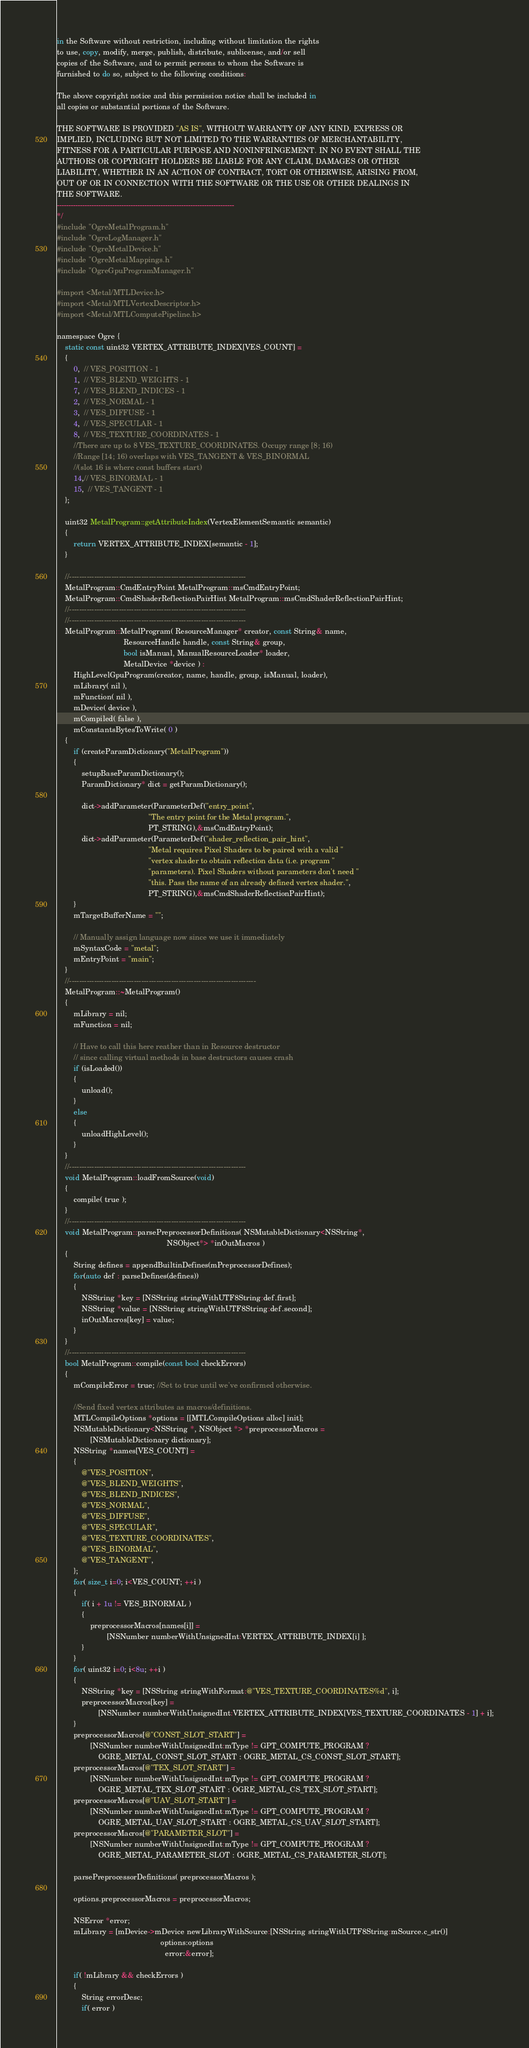<code> <loc_0><loc_0><loc_500><loc_500><_ObjectiveC_>in the Software without restriction, including without limitation the rights
to use, copy, modify, merge, publish, distribute, sublicense, and/or sell
copies of the Software, and to permit persons to whom the Software is
furnished to do so, subject to the following conditions:

The above copyright notice and this permission notice shall be included in
all copies or substantial portions of the Software.

THE SOFTWARE IS PROVIDED "AS IS", WITHOUT WARRANTY OF ANY KIND, EXPRESS OR
IMPLIED, INCLUDING BUT NOT LIMITED TO THE WARRANTIES OF MERCHANTABILITY,
FITNESS FOR A PARTICULAR PURPOSE AND NONINFRINGEMENT. IN NO EVENT SHALL THE
AUTHORS OR COPYRIGHT HOLDERS BE LIABLE FOR ANY CLAIM, DAMAGES OR OTHER
LIABILITY, WHETHER IN AN ACTION OF CONTRACT, TORT OR OTHERWISE, ARISING FROM,
OUT OF OR IN CONNECTION WITH THE SOFTWARE OR THE USE OR OTHER DEALINGS IN
THE SOFTWARE.
-----------------------------------------------------------------------------
*/
#include "OgreMetalProgram.h"
#include "OgreLogManager.h"
#include "OgreMetalDevice.h"
#include "OgreMetalMappings.h"
#include "OgreGpuProgramManager.h"

#import <Metal/MTLDevice.h>
#import <Metal/MTLVertexDescriptor.h>
#import <Metal/MTLComputePipeline.h>

namespace Ogre {
    static const uint32 VERTEX_ATTRIBUTE_INDEX[VES_COUNT] =
    {
        0,  // VES_POSITION - 1
        1,  // VES_BLEND_WEIGHTS - 1
        7,  // VES_BLEND_INDICES - 1
        2,  // VES_NORMAL - 1
        3,  // VES_DIFFUSE - 1
        4,  // VES_SPECULAR - 1
        8,  // VES_TEXTURE_COORDINATES - 1
        //There are up to 8 VES_TEXTURE_COORDINATES. Occupy range [8; 16)
        //Range [14; 16) overlaps with VES_TANGENT & VES_BINORMAL
        //(slot 16 is where const buffers start)
        14,// VES_BINORMAL - 1
        15,  // VES_TANGENT - 1
    };

    uint32 MetalProgram::getAttributeIndex(VertexElementSemantic semantic)
    {
        return VERTEX_ATTRIBUTE_INDEX[semantic - 1];
    }

    //-----------------------------------------------------------------------
    MetalProgram::CmdEntryPoint MetalProgram::msCmdEntryPoint;
    MetalProgram::CmdShaderReflectionPairHint MetalProgram::msCmdShaderReflectionPairHint;
    //-----------------------------------------------------------------------
    //-----------------------------------------------------------------------
    MetalProgram::MetalProgram( ResourceManager* creator, const String& name,
                                ResourceHandle handle, const String& group,
                                bool isManual, ManualResourceLoader* loader,
                                MetalDevice *device ) :
        HighLevelGpuProgram(creator, name, handle, group, isManual, loader),
        mLibrary( nil ),
        mFunction( nil ),
        mDevice( device ),
        mCompiled( false ),
        mConstantsBytesToWrite( 0 )
    {
        if (createParamDictionary("MetalProgram"))
        {
            setupBaseParamDictionary();
            ParamDictionary* dict = getParamDictionary();

            dict->addParameter(ParameterDef("entry_point",
                                            "The entry point for the Metal program.",
                                            PT_STRING),&msCmdEntryPoint);
            dict->addParameter(ParameterDef("shader_reflection_pair_hint",
                                            "Metal requires Pixel Shaders to be paired with a valid "
                                            "vertex shader to obtain reflection data (i.e. program "
                                            "parameters). Pixel Shaders without parameters don't need "
                                            "this. Pass the name of an already defined vertex shader.",
                                            PT_STRING),&msCmdShaderReflectionPairHint);
        }
        mTargetBufferName = "";

        // Manually assign language now since we use it immediately
        mSyntaxCode = "metal";
        mEntryPoint = "main";
    }
    //---------------------------------------------------------------------------
    MetalProgram::~MetalProgram()
    {
        mLibrary = nil;
        mFunction = nil;

        // Have to call this here reather than in Resource destructor
        // since calling virtual methods in base destructors causes crash
        if (isLoaded())
        {
            unload();
        }
        else
        {
            unloadHighLevel();
        }
    }
    //-----------------------------------------------------------------------
    void MetalProgram::loadFromSource(void)
    {
        compile( true );
    }
    //-----------------------------------------------------------------------
    void MetalProgram::parsePreprocessorDefinitions( NSMutableDictionary<NSString*,
                                                     NSObject*> *inOutMacros )
    {
        String defines = appendBuiltinDefines(mPreprocessorDefines);
        for(auto def : parseDefines(defines))
        {
            NSString *key = [NSString stringWithUTF8String:def.first];
            NSString *value = [NSString stringWithUTF8String:def.second];
            inOutMacros[key] = value;
        }
    }
    //-----------------------------------------------------------------------
    bool MetalProgram::compile(const bool checkErrors)
    {
        mCompileError = true; //Set to true until we've confirmed otherwise.

        //Send fixed vertex attributes as macros/definitions.
        MTLCompileOptions *options = [[MTLCompileOptions alloc] init];
        NSMutableDictionary<NSString *, NSObject *> *preprocessorMacros =
                [NSMutableDictionary dictionary];
        NSString *names[VES_COUNT] =
        {
            @"VES_POSITION",
            @"VES_BLEND_WEIGHTS",
            @"VES_BLEND_INDICES",
            @"VES_NORMAL",
            @"VES_DIFFUSE",
            @"VES_SPECULAR",
            @"VES_TEXTURE_COORDINATES",
            @"VES_BINORMAL",
            @"VES_TANGENT",
        };
        for( size_t i=0; i<VES_COUNT; ++i )
        {
            if( i + 1u != VES_BINORMAL )
            {
                preprocessorMacros[names[i]] =
                        [NSNumber numberWithUnsignedInt:VERTEX_ATTRIBUTE_INDEX[i] ];
            }
        }
        for( uint32 i=0; i<8u; ++i )
        {
            NSString *key = [NSString stringWithFormat:@"VES_TEXTURE_COORDINATES%d", i];
            preprocessorMacros[key] =
                    [NSNumber numberWithUnsignedInt:VERTEX_ATTRIBUTE_INDEX[VES_TEXTURE_COORDINATES - 1] + i];
        }
        preprocessorMacros[@"CONST_SLOT_START"] =
                [NSNumber numberWithUnsignedInt:mType != GPT_COMPUTE_PROGRAM ?
                    OGRE_METAL_CONST_SLOT_START : OGRE_METAL_CS_CONST_SLOT_START];
        preprocessorMacros[@"TEX_SLOT_START"] =
                [NSNumber numberWithUnsignedInt:mType != GPT_COMPUTE_PROGRAM ?
                    OGRE_METAL_TEX_SLOT_START : OGRE_METAL_CS_TEX_SLOT_START];
        preprocessorMacros[@"UAV_SLOT_START"] =
                [NSNumber numberWithUnsignedInt:mType != GPT_COMPUTE_PROGRAM ?
                    OGRE_METAL_UAV_SLOT_START : OGRE_METAL_CS_UAV_SLOT_START];
        preprocessorMacros[@"PARAMETER_SLOT"] =
                [NSNumber numberWithUnsignedInt:mType != GPT_COMPUTE_PROGRAM ?
                    OGRE_METAL_PARAMETER_SLOT : OGRE_METAL_CS_PARAMETER_SLOT];

        parsePreprocessorDefinitions( preprocessorMacros );

        options.preprocessorMacros = preprocessorMacros;

        NSError *error;
        mLibrary = [mDevice->mDevice newLibraryWithSource:[NSString stringWithUTF8String:mSource.c_str()]
                                                  options:options
                                                    error:&error];

        if( !mLibrary && checkErrors )
        {
            String errorDesc;
            if( error )</code> 